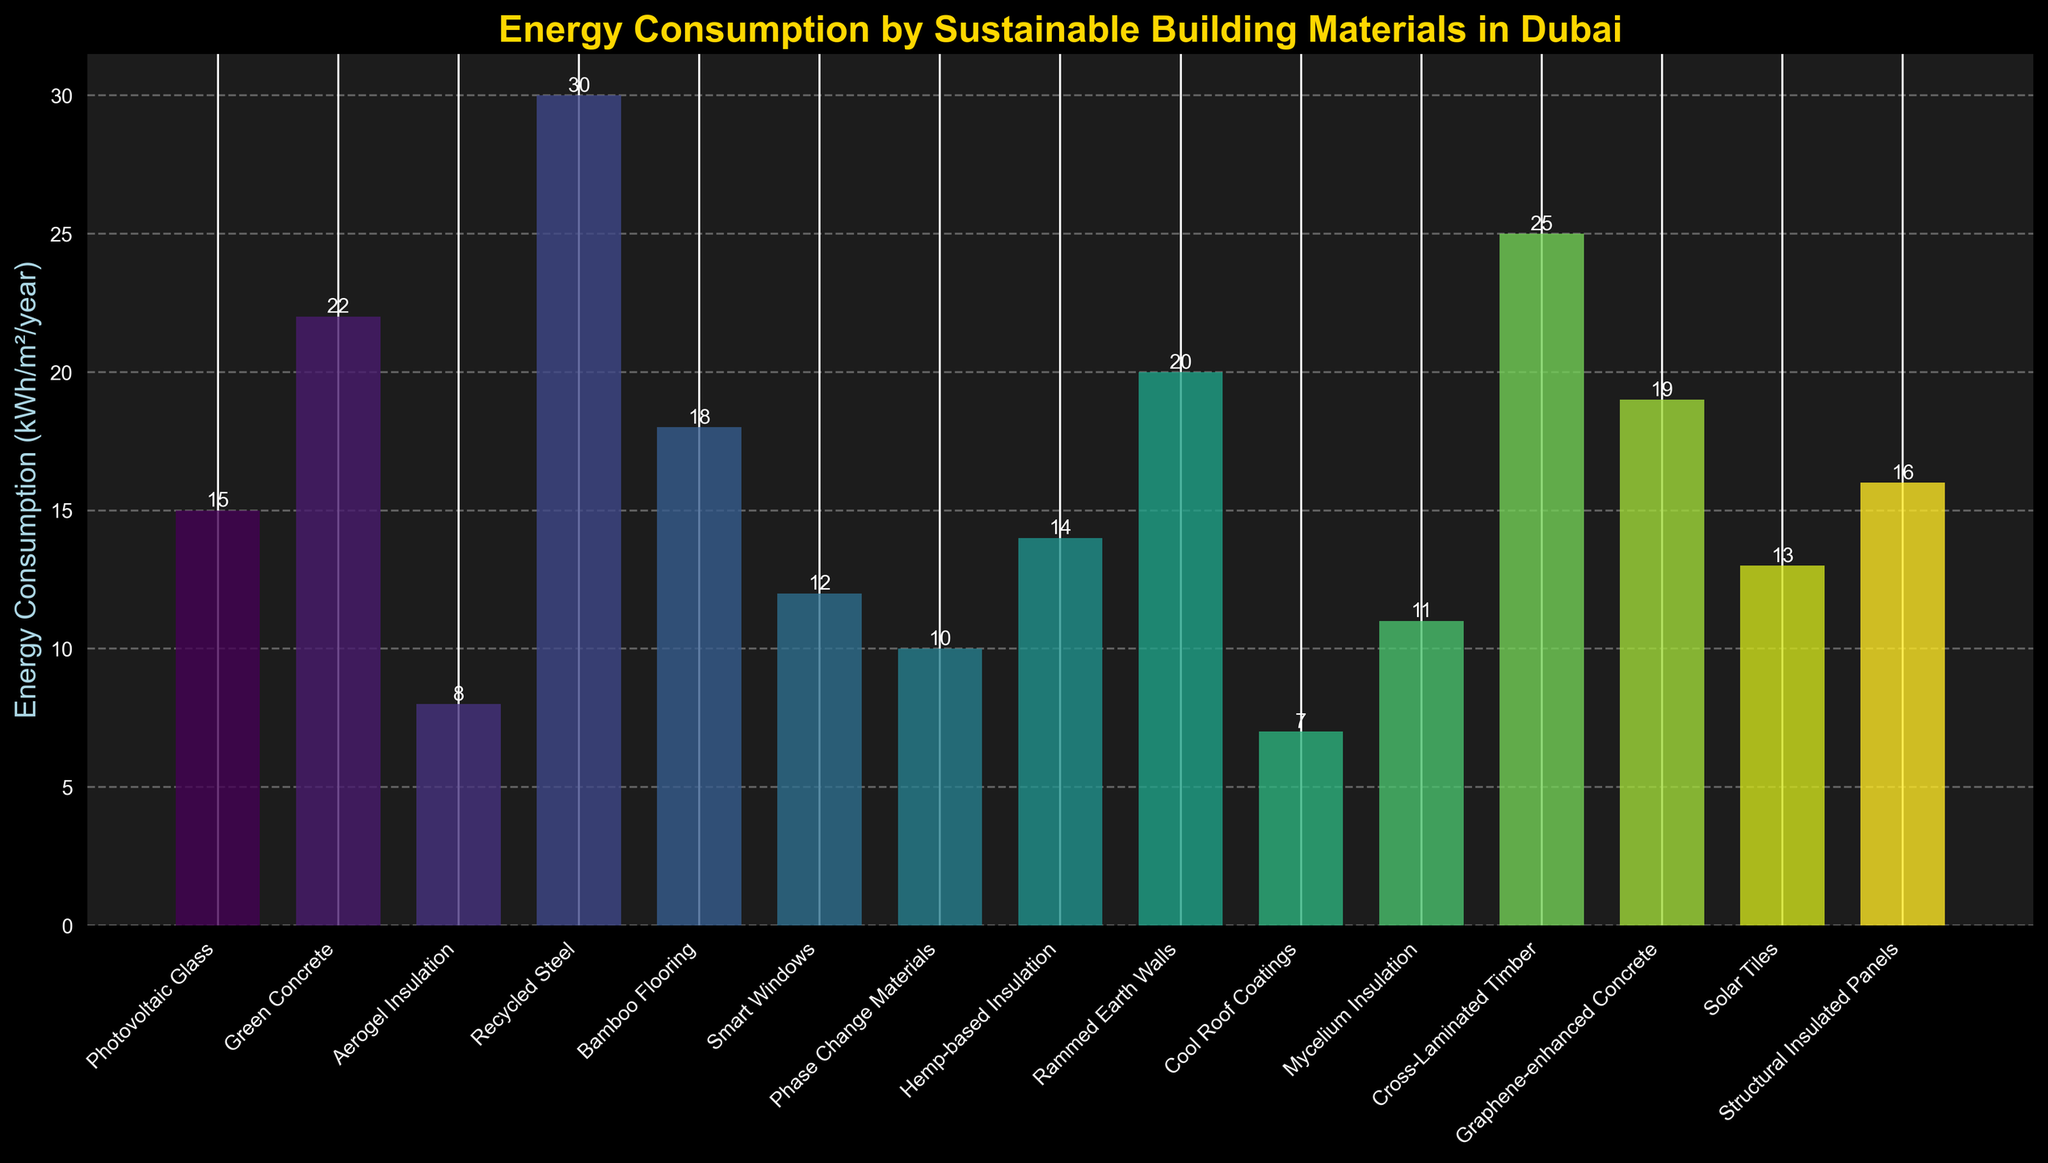What material has the highest energy consumption? By looking at the bar chart, the tallest bar indicates the highest energy consumption. Recycled Steel has the highest bar with an energy consumption of 30 kWh/m²/year.
Answer: Recycled Steel What's the total energy consumption of Green Concrete and Rammed Earth Walls? First, identify the bars corresponding to Green Concrete and Rammed Earth Walls, which have energy consumptions of 22 kWh/m²/year and 20 kWh/m²/year respectively. Adding them together gives us 22 + 20 = 42 kWh/m²/year.
Answer: 42 kWh/m²/year Among Smart Windows and Mycelium Insulation, which material has a lower energy consumption? Look at the bar heights for Smart Windows and Mycelium Insulation. Smart Windows have an energy consumption of 12 kWh/m²/year and Mycelium Insulation has 11 kWh/m²/year. Therefore, Mycelium Insulation has a lower energy consumption.
Answer: Mycelium Insulation What is the average energy consumption of Photovoltaic Glass, Aerogel Insulation, and Bamboo Flooring? First, sum the energy consumption values: Photovoltaic Glass (15) + Aerogel Insulation (8) + Bamboo Flooring (18) = 41. Then, divide this sum by the number of materials (3): 41/3 ≈ 13.67 kWh/m²/year.
Answer: 13.67 kWh/m²/year Which material has the closest energy consumption to the average of all materials? Calculate the average energy consumption of all materials: (15 + 22 + 8 + 30 + 18 + 12 + 10 + 14 + 20 + 7 + 11 + 25 + 19 + 13 + 16) / 15 ≈ 16.07 kWh/m²/year. Then, compare each material’s energy consumption to find the closest value. Structural Insulated Panels at 16 kWh/m²/year is the closest.
Answer: Structural Insulated Panels Is the energy consumption of Cross-Laminated Timber greater than the combined energy consumption of Cool Roof Coatings and Hemp-based Insulation? First, obtain the values: Cross-Laminated Timber is 25 kWh/m²/year, Cool Roof Coatings is 7 kWh/m²/year, and Hemp-based Insulation is 14 kWh/m²/year. Combine Cool Roof Coatings and Hemp-based Insulation: 7 + 14 = 21 kWh/m²/year. Since 25 kWh/m²/year is greater than 21 kWh/m²/year, the answer is yes.
Answer: Yes Rank the materials with the lowest to highest energy consumption. Arrange the energy consumption values in ascending order: Cool Roof Coatings (7), Aerogel Insulation (8), Phase Change Materials (10), Mycelium Insulation (11), Smart Windows (12), Solar Tiles (13), Hemp-based Insulation (14), Photovoltaic Glass (15), Structural Insulated Panels (16), Bamboo Flooring (18), Graphene-enhanced Concrete (19), Rammed Earth Walls (20), Green Concrete (22), Cross-Laminated Timber (25), Recycled Steel (30).
Answer: Cool Roof Coatings, Aerogel Insulation, Phase Change Materials, Mycelium Insulation, Smart Windows, Solar Tiles, Hemp-based Insulation, Photovoltaic Glass, Structural Insulated Panels, Bamboo Flooring, Graphene-enhanced Concrete, Rammed Earth Walls, Green Concrete, Cross-Laminated Timber, Recycled Steel What's the difference in energy consumption between the least and the most energy-consuming materials? The least energy-consuming material is Cool Roof Coatings (7 kWh/m²/year) and the most energy-consuming material is Recycled Steel (30 kWh/m²/year). The difference is 30 - 7 = 23 kWh/m²/year.
Answer: 23 kWh/m²/year Out of Bamboo Flooring, Graphene-enhanced Concrete, and Solar Tiles, which has the highest energy consumption? Identify the bar heights for Bamboo Flooring (18), Graphene-enhanced Concrete (19), and Solar Tiles (13). Among these, Graphene-enhanced Concrete has the highest energy consumption at 19 kWh/m²/year.
Answer: Graphene-enhanced Concrete 